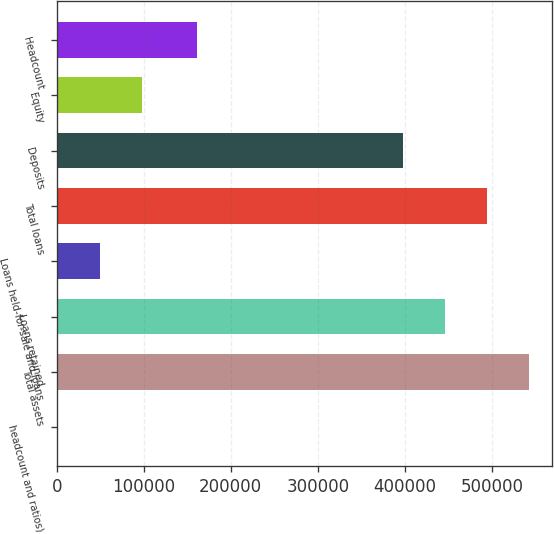<chart> <loc_0><loc_0><loc_500><loc_500><bar_chart><fcel>headcount and ratios)<fcel>Total assets<fcel>Loans retained<fcel>Loans held-for-sale and loans<fcel>Total loans<fcel>Deposits<fcel>Equity<fcel>Headcount<nl><fcel>2011<fcel>542214<fcel>445955<fcel>50140.6<fcel>494084<fcel>397825<fcel>98270.2<fcel>161443<nl></chart> 